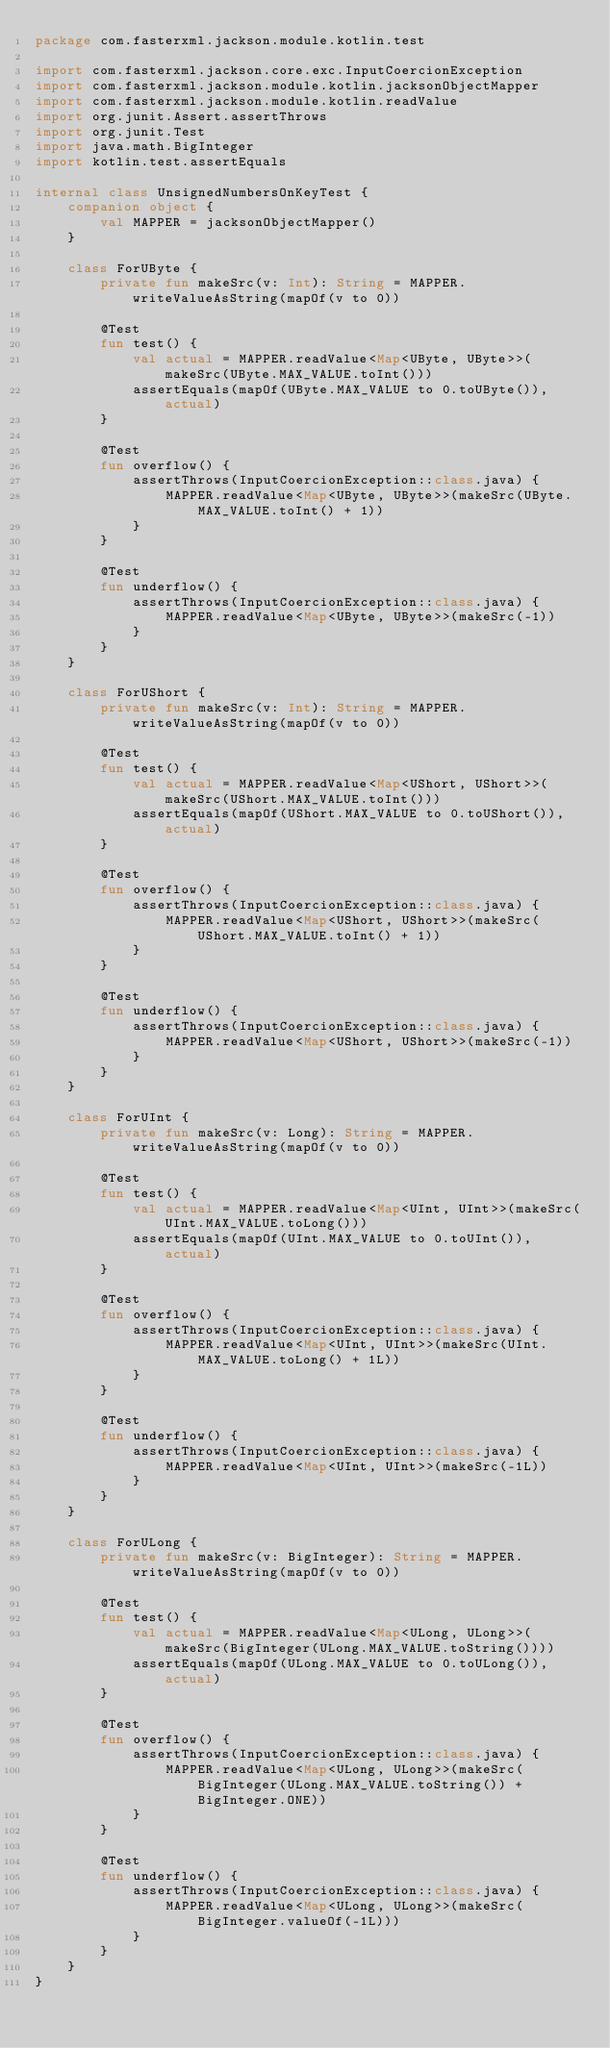<code> <loc_0><loc_0><loc_500><loc_500><_Kotlin_>package com.fasterxml.jackson.module.kotlin.test

import com.fasterxml.jackson.core.exc.InputCoercionException
import com.fasterxml.jackson.module.kotlin.jacksonObjectMapper
import com.fasterxml.jackson.module.kotlin.readValue
import org.junit.Assert.assertThrows
import org.junit.Test
import java.math.BigInteger
import kotlin.test.assertEquals

internal class UnsignedNumbersOnKeyTest {
    companion object {
        val MAPPER = jacksonObjectMapper()
    }

    class ForUByte {
        private fun makeSrc(v: Int): String = MAPPER.writeValueAsString(mapOf(v to 0))

        @Test
        fun test() {
            val actual = MAPPER.readValue<Map<UByte, UByte>>(makeSrc(UByte.MAX_VALUE.toInt()))
            assertEquals(mapOf(UByte.MAX_VALUE to 0.toUByte()), actual)
        }

        @Test
        fun overflow() {
            assertThrows(InputCoercionException::class.java) {
                MAPPER.readValue<Map<UByte, UByte>>(makeSrc(UByte.MAX_VALUE.toInt() + 1))
            }
        }

        @Test
        fun underflow() {
            assertThrows(InputCoercionException::class.java) {
                MAPPER.readValue<Map<UByte, UByte>>(makeSrc(-1))
            }
        }
    }

    class ForUShort {
        private fun makeSrc(v: Int): String = MAPPER.writeValueAsString(mapOf(v to 0))

        @Test
        fun test() {
            val actual = MAPPER.readValue<Map<UShort, UShort>>(makeSrc(UShort.MAX_VALUE.toInt()))
            assertEquals(mapOf(UShort.MAX_VALUE to 0.toUShort()), actual)
        }

        @Test
        fun overflow() {
            assertThrows(InputCoercionException::class.java) {
                MAPPER.readValue<Map<UShort, UShort>>(makeSrc(UShort.MAX_VALUE.toInt() + 1))
            }
        }

        @Test
        fun underflow() {
            assertThrows(InputCoercionException::class.java) {
                MAPPER.readValue<Map<UShort, UShort>>(makeSrc(-1))
            }
        }
    }

    class ForUInt {
        private fun makeSrc(v: Long): String = MAPPER.writeValueAsString(mapOf(v to 0))

        @Test
        fun test() {
            val actual = MAPPER.readValue<Map<UInt, UInt>>(makeSrc(UInt.MAX_VALUE.toLong()))
            assertEquals(mapOf(UInt.MAX_VALUE to 0.toUInt()), actual)
        }

        @Test
        fun overflow() {
            assertThrows(InputCoercionException::class.java) {
                MAPPER.readValue<Map<UInt, UInt>>(makeSrc(UInt.MAX_VALUE.toLong() + 1L))
            }
        }

        @Test
        fun underflow() {
            assertThrows(InputCoercionException::class.java) {
                MAPPER.readValue<Map<UInt, UInt>>(makeSrc(-1L))
            }
        }
    }

    class ForULong {
        private fun makeSrc(v: BigInteger): String = MAPPER.writeValueAsString(mapOf(v to 0))

        @Test
        fun test() {
            val actual = MAPPER.readValue<Map<ULong, ULong>>(makeSrc(BigInteger(ULong.MAX_VALUE.toString())))
            assertEquals(mapOf(ULong.MAX_VALUE to 0.toULong()), actual)
        }

        @Test
        fun overflow() {
            assertThrows(InputCoercionException::class.java) {
                MAPPER.readValue<Map<ULong, ULong>>(makeSrc(BigInteger(ULong.MAX_VALUE.toString()) + BigInteger.ONE))
            }
        }

        @Test
        fun underflow() {
            assertThrows(InputCoercionException::class.java) {
                MAPPER.readValue<Map<ULong, ULong>>(makeSrc(BigInteger.valueOf(-1L)))
            }
        }
    }
}
</code> 